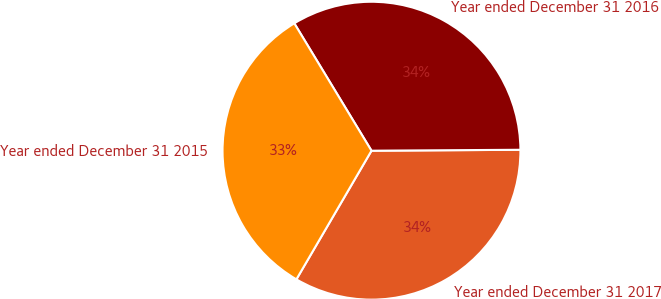<chart> <loc_0><loc_0><loc_500><loc_500><pie_chart><fcel>Year ended December 31 2017<fcel>Year ended December 31 2016<fcel>Year ended December 31 2015<nl><fcel>33.51%<fcel>33.57%<fcel>32.92%<nl></chart> 